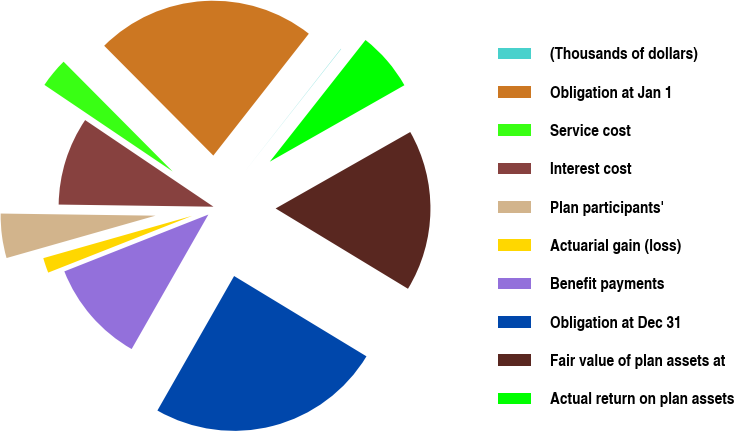Convert chart. <chart><loc_0><loc_0><loc_500><loc_500><pie_chart><fcel>(Thousands of dollars)<fcel>Obligation at Jan 1<fcel>Service cost<fcel>Interest cost<fcel>Plan participants'<fcel>Actuarial gain (loss)<fcel>Benefit payments<fcel>Obligation at Dec 31<fcel>Fair value of plan assets at<fcel>Actual return on plan assets<nl><fcel>0.03%<fcel>23.03%<fcel>3.1%<fcel>9.23%<fcel>4.63%<fcel>1.57%<fcel>10.77%<fcel>24.57%<fcel>16.9%<fcel>6.17%<nl></chart> 